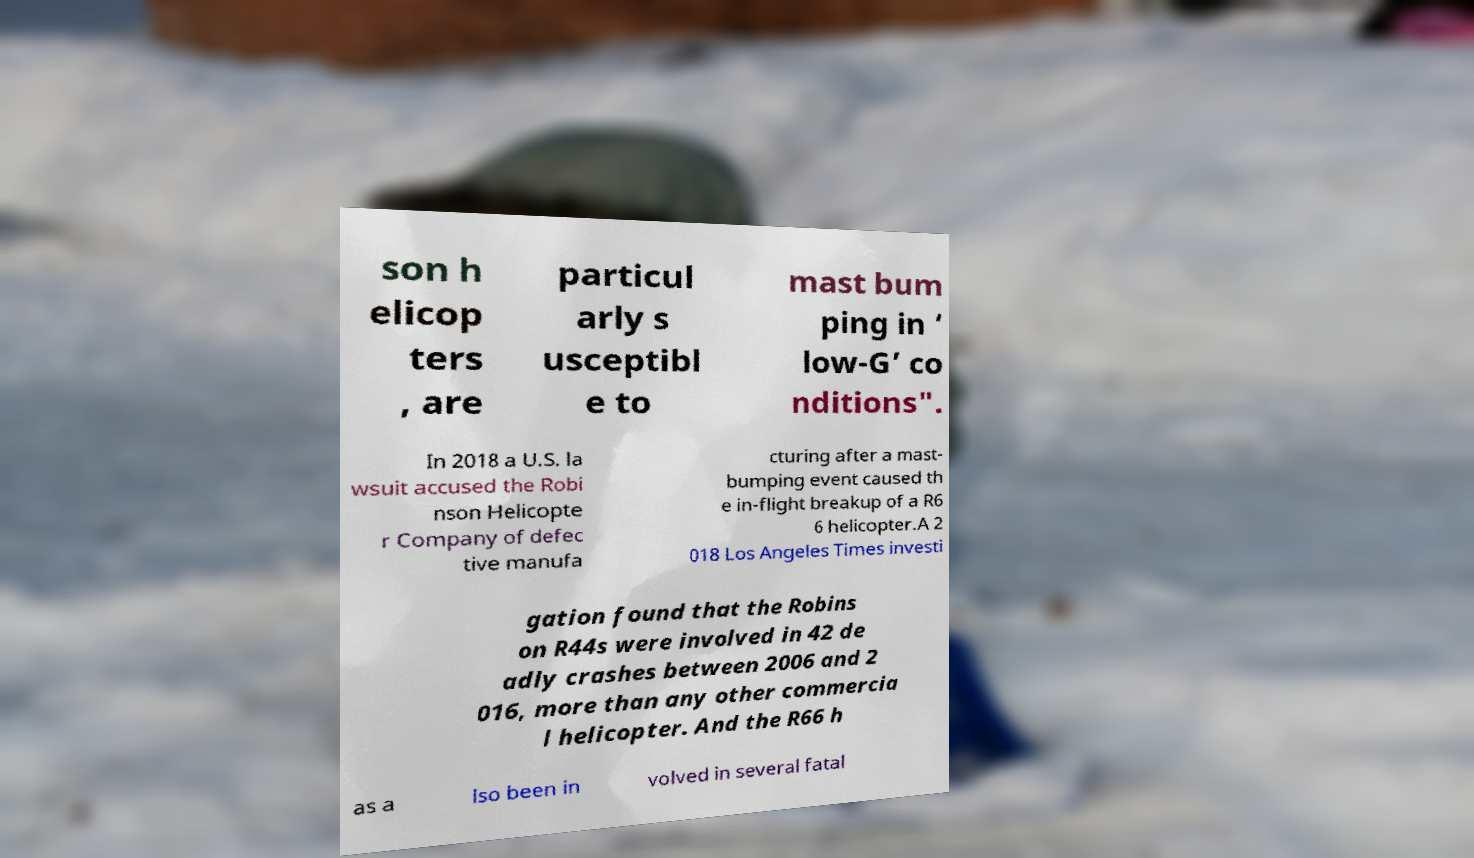Please read and relay the text visible in this image. What does it say? son h elicop ters , are particul arly s usceptibl e to mast bum ping in ‘ low-G’ co nditions". In 2018 a U.S. la wsuit accused the Robi nson Helicopte r Company of defec tive manufa cturing after a mast- bumping event caused th e in-flight breakup of a R6 6 helicopter.A 2 018 Los Angeles Times investi gation found that the Robins on R44s were involved in 42 de adly crashes between 2006 and 2 016, more than any other commercia l helicopter. And the R66 h as a lso been in volved in several fatal 